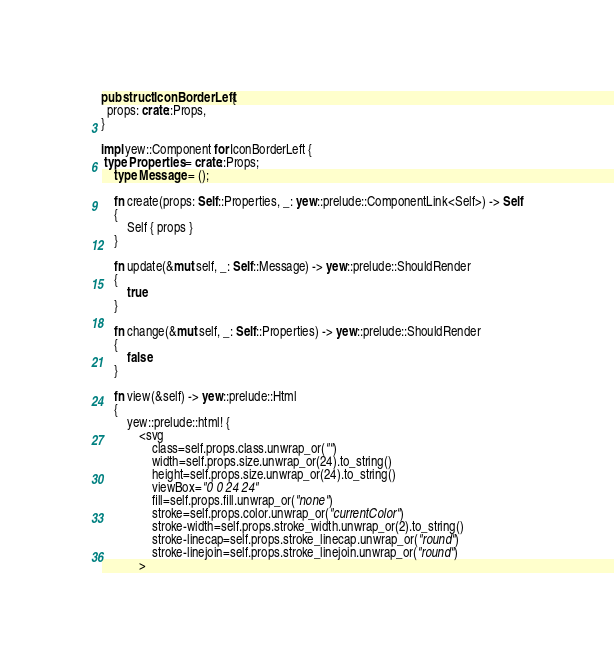<code> <loc_0><loc_0><loc_500><loc_500><_Rust_>
pub struct IconBorderLeft {
  props: crate::Props,
}

impl yew::Component for IconBorderLeft {
 type Properties = crate::Props;
    type Message = ();

    fn create(props: Self::Properties, _: yew::prelude::ComponentLink<Self>) -> Self
    {
        Self { props }
    }

    fn update(&mut self, _: Self::Message) -> yew::prelude::ShouldRender
    {
        true
    }

    fn change(&mut self, _: Self::Properties) -> yew::prelude::ShouldRender
    {
        false
    }

    fn view(&self) -> yew::prelude::Html
    {
        yew::prelude::html! {
            <svg
                class=self.props.class.unwrap_or("")
                width=self.props.size.unwrap_or(24).to_string()
                height=self.props.size.unwrap_or(24).to_string()
                viewBox="0 0 24 24"
                fill=self.props.fill.unwrap_or("none")
                stroke=self.props.color.unwrap_or("currentColor")
                stroke-width=self.props.stroke_width.unwrap_or(2).to_string()
                stroke-linecap=self.props.stroke_linecap.unwrap_or("round")
                stroke-linejoin=self.props.stroke_linejoin.unwrap_or("round")
            ></code> 